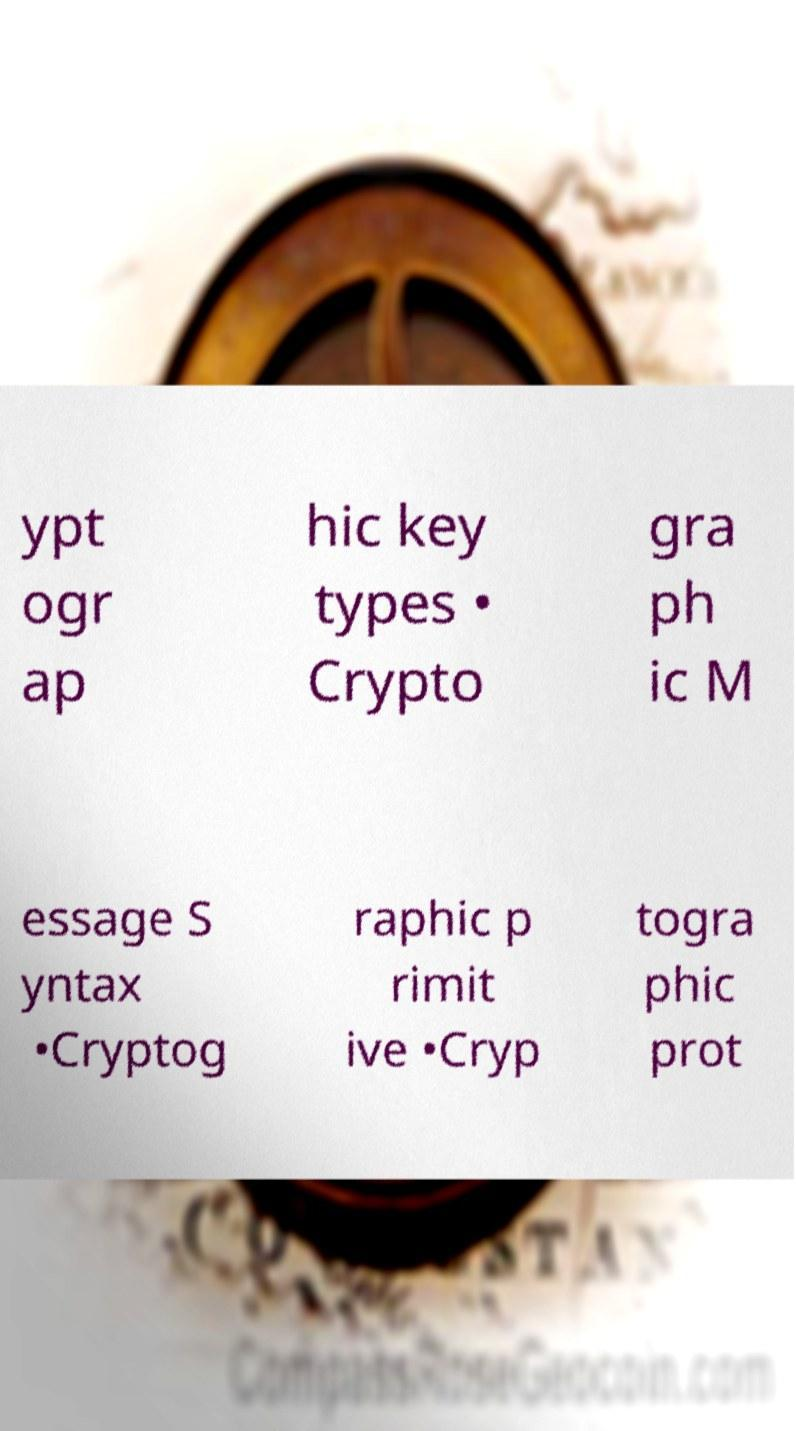For documentation purposes, I need the text within this image transcribed. Could you provide that? ypt ogr ap hic key types • Crypto gra ph ic M essage S yntax •Cryptog raphic p rimit ive •Cryp togra phic prot 